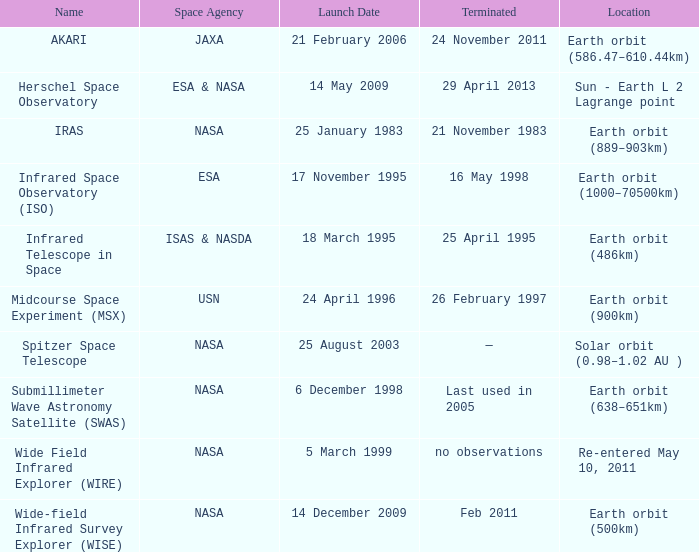When was the wide field infrared explorer (wire) launched by nasa? 5 March 1999. 